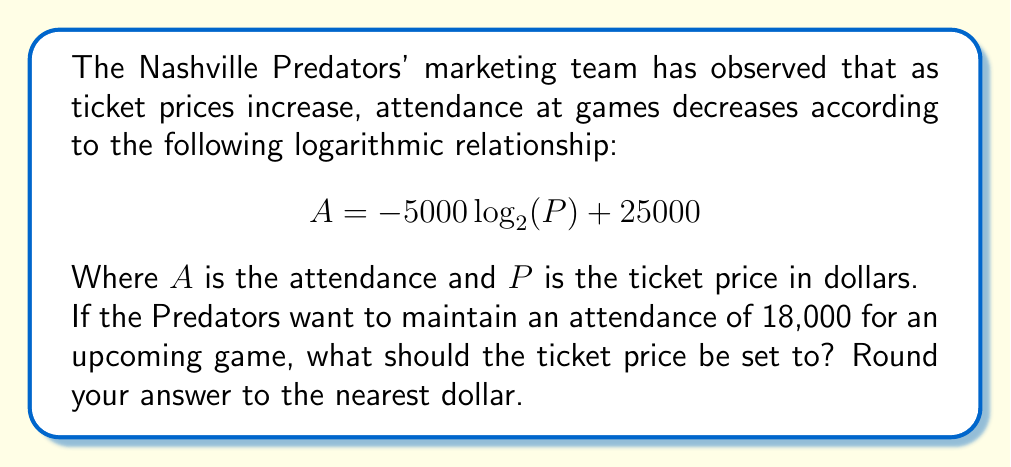Can you solve this math problem? To solve this problem, we need to use the given logarithmic equation and solve for $P$. Let's approach this step-by-step:

1) We start with the equation:
   $A = -5000 \log_2(P) + 25000$

2) We know that $A = 18000$, so we can substitute this:
   $18000 = -5000 \log_2(P) + 25000$

3) Subtract 25000 from both sides:
   $-7000 = -5000 \log_2(P)$

4) Divide both sides by -5000:
   $1.4 = \log_2(P)$

5) To solve for $P$, we need to apply the inverse function of $\log_2$, which is $2^x$:
   $2^{1.4} = P$

6) Calculate this value:
   $P \approx 2.6390158215$

7) Rounding to the nearest dollar:
   $P \approx 26$

Therefore, the ticket price should be set to $26 to maintain an attendance of 18,000.
Answer: $26 